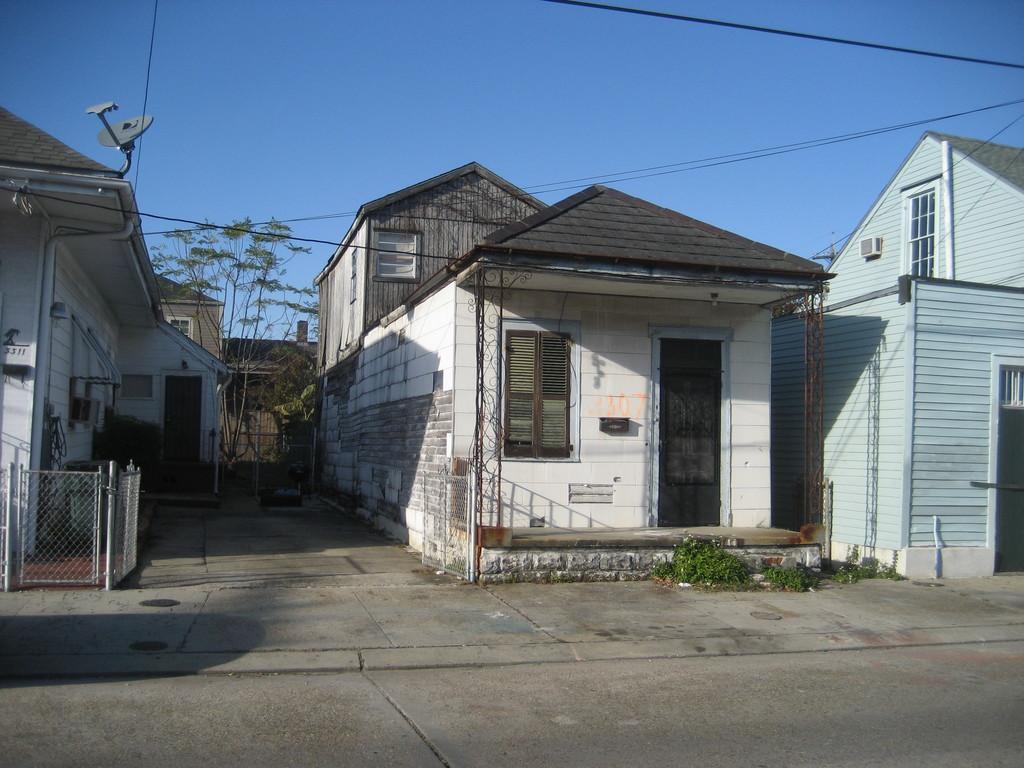In one or two sentences, can you explain what this image depicts? In this picture we can see a road, beside this road we can see buildings, trees, grass, here we can see an antenna, wires and we can see sky in the background. 